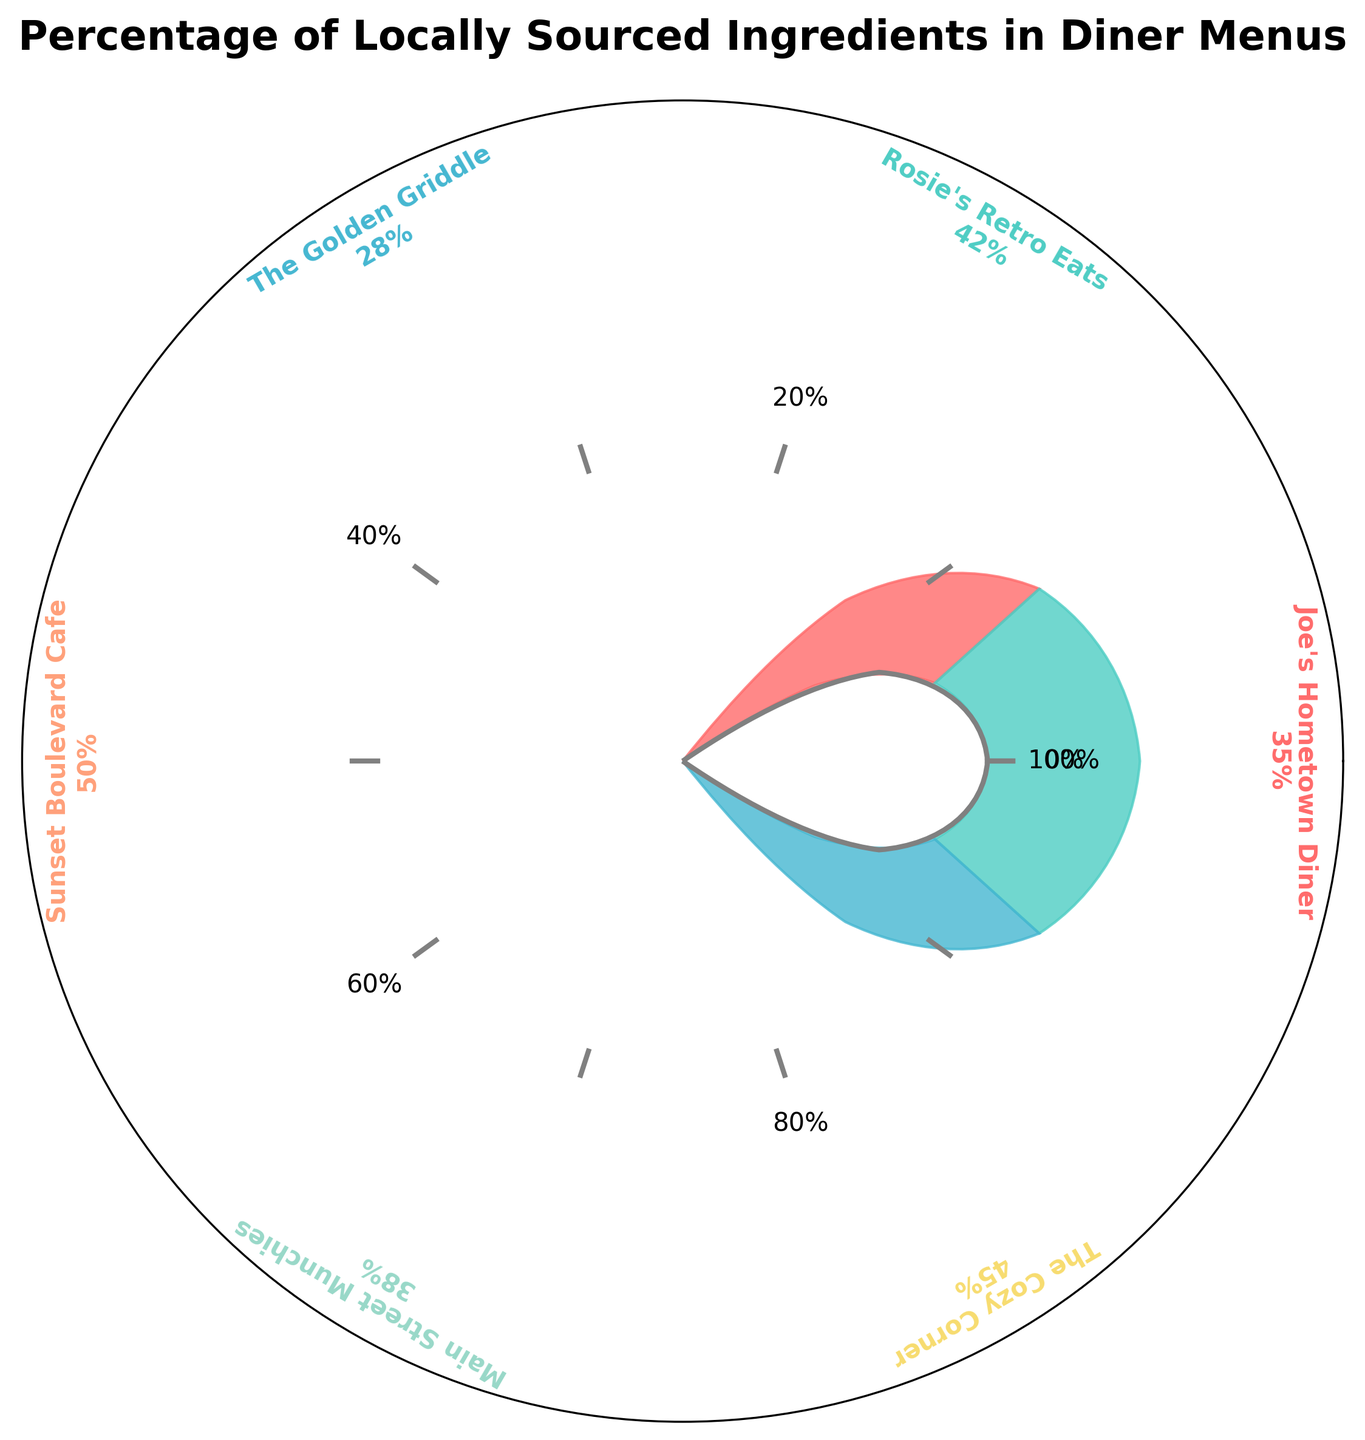What diner has the highest percentage of locally sourced ingredients? To find the diner with the highest percentage, we need to look at the percentages indicated next to each restaurant name. The highest percentage is 50%, which belongs to Sunset Boulevard Cafe.
Answer: Sunset Boulevard Cafe Which diner has the lowest percentage of locally sourced ingredients? To identify the diner with the lowest percentage, we review the percentages provided next to each restaurant name. The lowest percentage is 28%, which is attributed to The Golden Griddle.
Answer: The Golden Griddle What is the average percentage of locally sourced ingredients for all diners? To calculate the average, sum up all the percentages and then divide by the number of diners. (35 + 42 + 28 + 50 + 38 + 45) / 6 = 238 / 6 = 39.67%
Answer: 39.67% How many diners have a percentage of locally sourced ingredients greater than 40%? Count the number of diners with percentages above 40%. These are Rosie's Retro Eats (42%), Sunset Boulevard Cafe (50%), and The Cozy Corner (45%), making a total of three diners.
Answer: 3 Which diners have a percentage of locally sourced ingredients within 10% of the average? First, calculate the average (39.67%). Then find diners with percentages within the range of 29.67% to 49.67%. These diners are Joe's Hometown Diner (35%), Rosie's Retro Eats (42%), Main Street Munchies (38%), and The Cozy Corner (45%).
Answer: Joe's Hometown Diner, Rosie's Retro Eats, Main Street Munchies, The Cozy Corner Compare the percentage of locally sourced ingredients between Joe's Hometown Diner and The Golden Griddle. Looking at the figure, Joe's Hometown Diner has 35% while The Golden Griddle has 28%. Calculate the difference: 35% - 28% = 7%.
Answer: 7% What is the range of percentages for the diners? Identify the highest and lowest percentages, which are 50% for Sunset Boulevard Cafe and 28% for The Golden Griddle, respectively. To find the range, subtract the lowest percentage from the highest: 50% - 28% = 22%.
Answer: 22% How many diners have less than 40% of locally sourced ingredients? Count the number of diners with percentages under 40%. These are Joe's Hometown Diner (35%), The Golden Griddle (28%), and Main Street Munchies (38%), making a total of three diners.
Answer: 3 